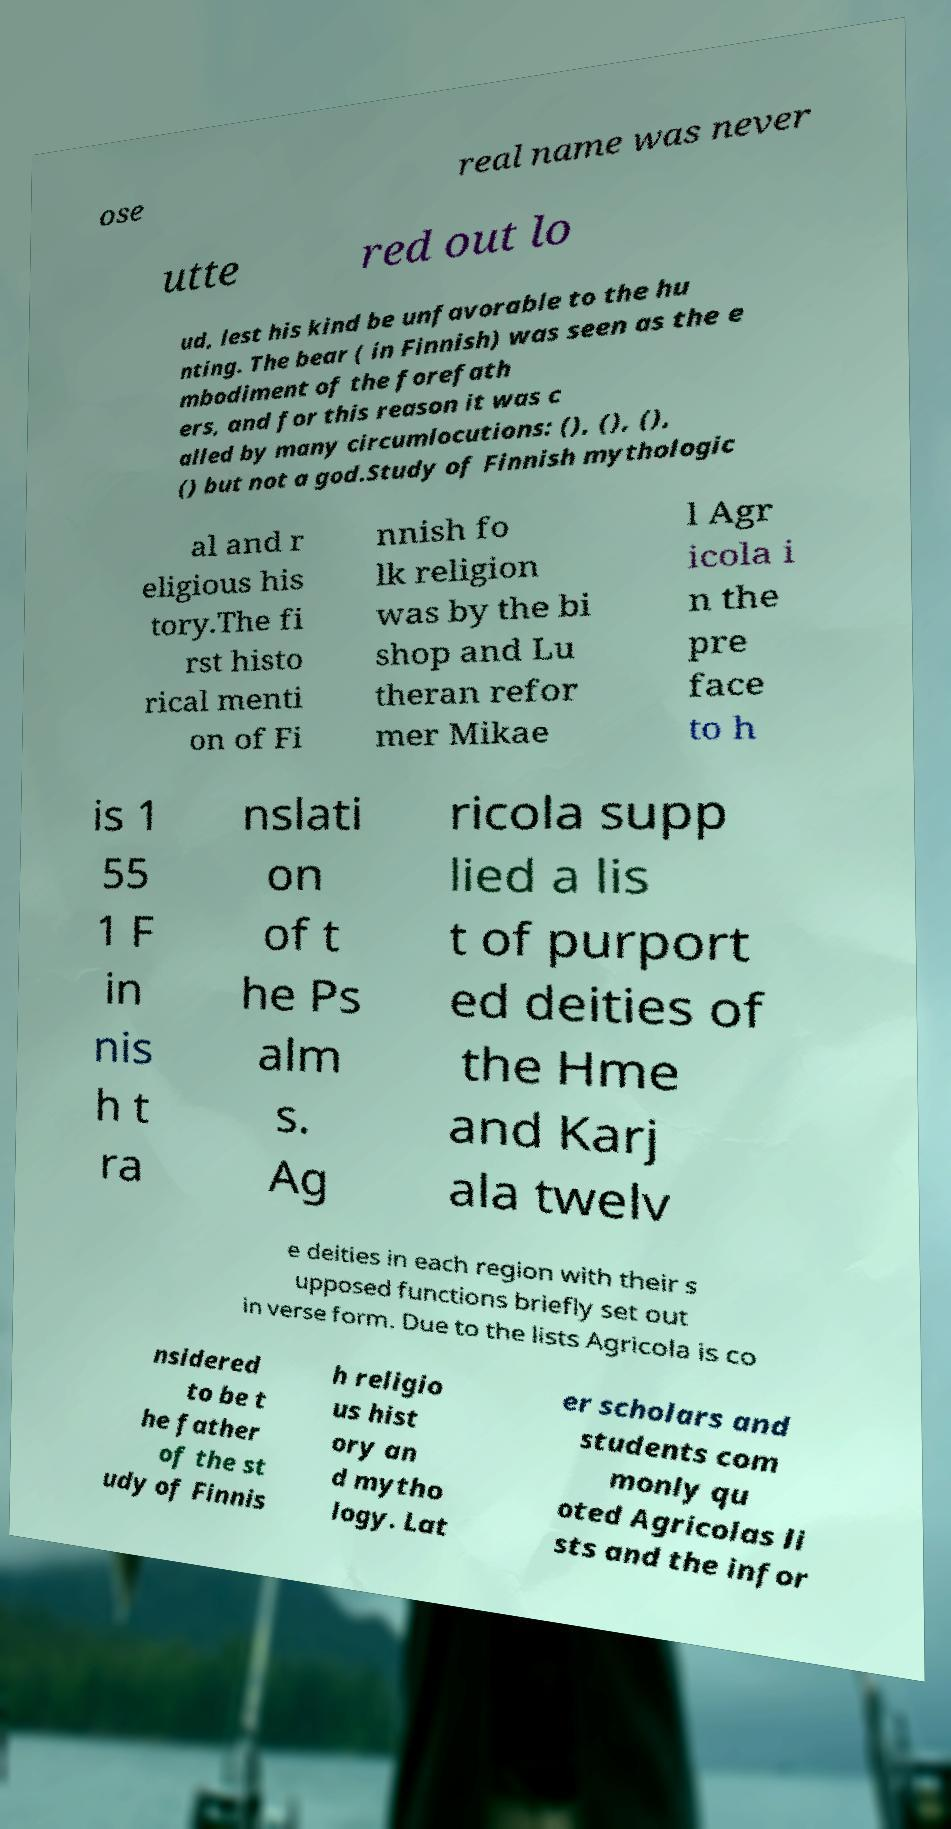There's text embedded in this image that I need extracted. Can you transcribe it verbatim? ose real name was never utte red out lo ud, lest his kind be unfavorable to the hu nting. The bear ( in Finnish) was seen as the e mbodiment of the forefath ers, and for this reason it was c alled by many circumlocutions: (), (), (), () but not a god.Study of Finnish mythologic al and r eligious his tory.The fi rst histo rical menti on of Fi nnish fo lk religion was by the bi shop and Lu theran refor mer Mikae l Agr icola i n the pre face to h is 1 55 1 F in nis h t ra nslati on of t he Ps alm s. Ag ricola supp lied a lis t of purport ed deities of the Hme and Karj ala twelv e deities in each region with their s upposed functions briefly set out in verse form. Due to the lists Agricola is co nsidered to be t he father of the st udy of Finnis h religio us hist ory an d mytho logy. Lat er scholars and students com monly qu oted Agricolas li sts and the infor 